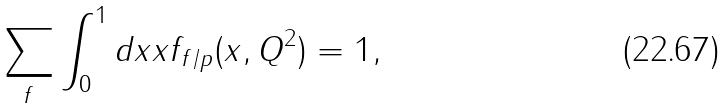Convert formula to latex. <formula><loc_0><loc_0><loc_500><loc_500>\sum _ { f } \int _ { 0 } ^ { 1 } d x x f _ { f / p } ( x , Q ^ { 2 } ) = 1 ,</formula> 